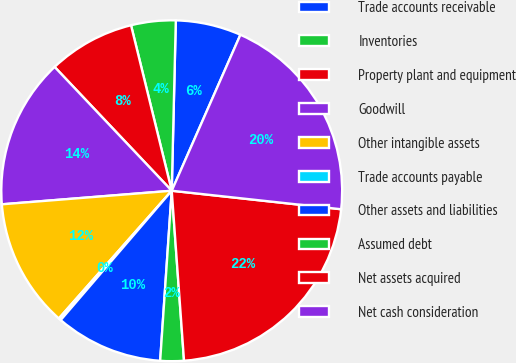Convert chart to OTSL. <chart><loc_0><loc_0><loc_500><loc_500><pie_chart><fcel>Trade accounts receivable<fcel>Inventories<fcel>Property plant and equipment<fcel>Goodwill<fcel>Other intangible assets<fcel>Trade accounts payable<fcel>Other assets and liabilities<fcel>Assumed debt<fcel>Net assets acquired<fcel>Net cash consideration<nl><fcel>6.22%<fcel>4.22%<fcel>8.22%<fcel>14.21%<fcel>12.21%<fcel>0.23%<fcel>10.21%<fcel>2.23%<fcel>22.12%<fcel>20.13%<nl></chart> 